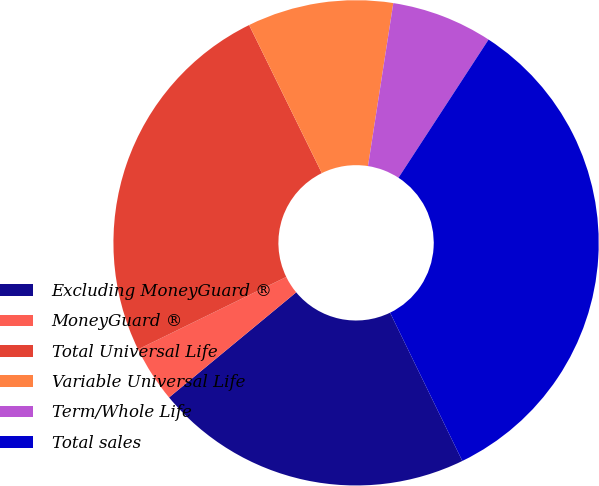<chart> <loc_0><loc_0><loc_500><loc_500><pie_chart><fcel>Excluding MoneyGuard ®<fcel>MoneyGuard ®<fcel>Total Universal Life<fcel>Variable Universal Life<fcel>Term/Whole Life<fcel>Total sales<nl><fcel>21.22%<fcel>3.76%<fcel>24.97%<fcel>9.72%<fcel>6.74%<fcel>33.59%<nl></chart> 